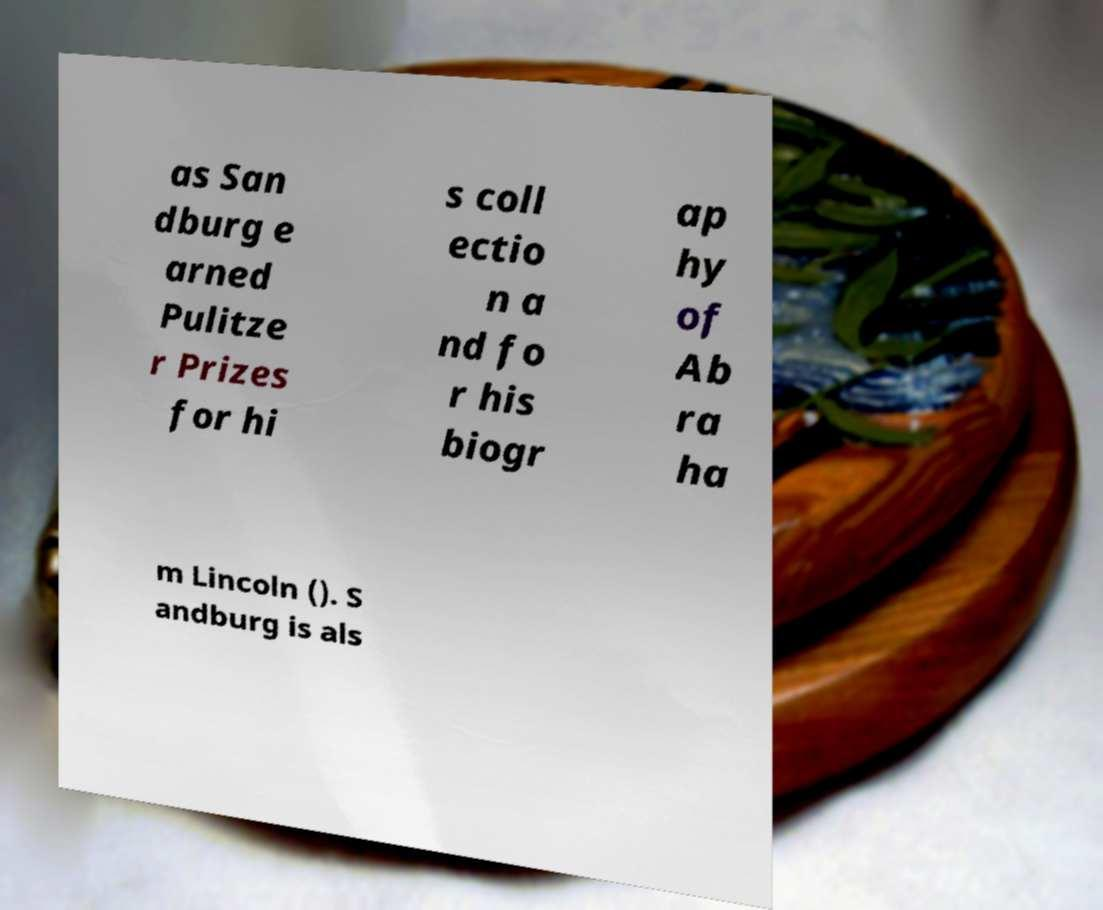I need the written content from this picture converted into text. Can you do that? as San dburg e arned Pulitze r Prizes for hi s coll ectio n a nd fo r his biogr ap hy of Ab ra ha m Lincoln (). S andburg is als 